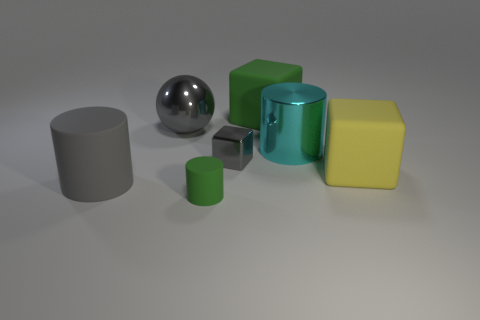Are there any patterns or symmetry in the arrangement of the objects? The arrangement of the objects doesn't conform to any strict pattern or symmetry. The objects are placed in a somewhat linear configuration without mirroring or repetition. Despite the lack of explicit patterning, there is a harmonious balance created by the variation in shapes and sizes that provides a visually pleasing composition. 